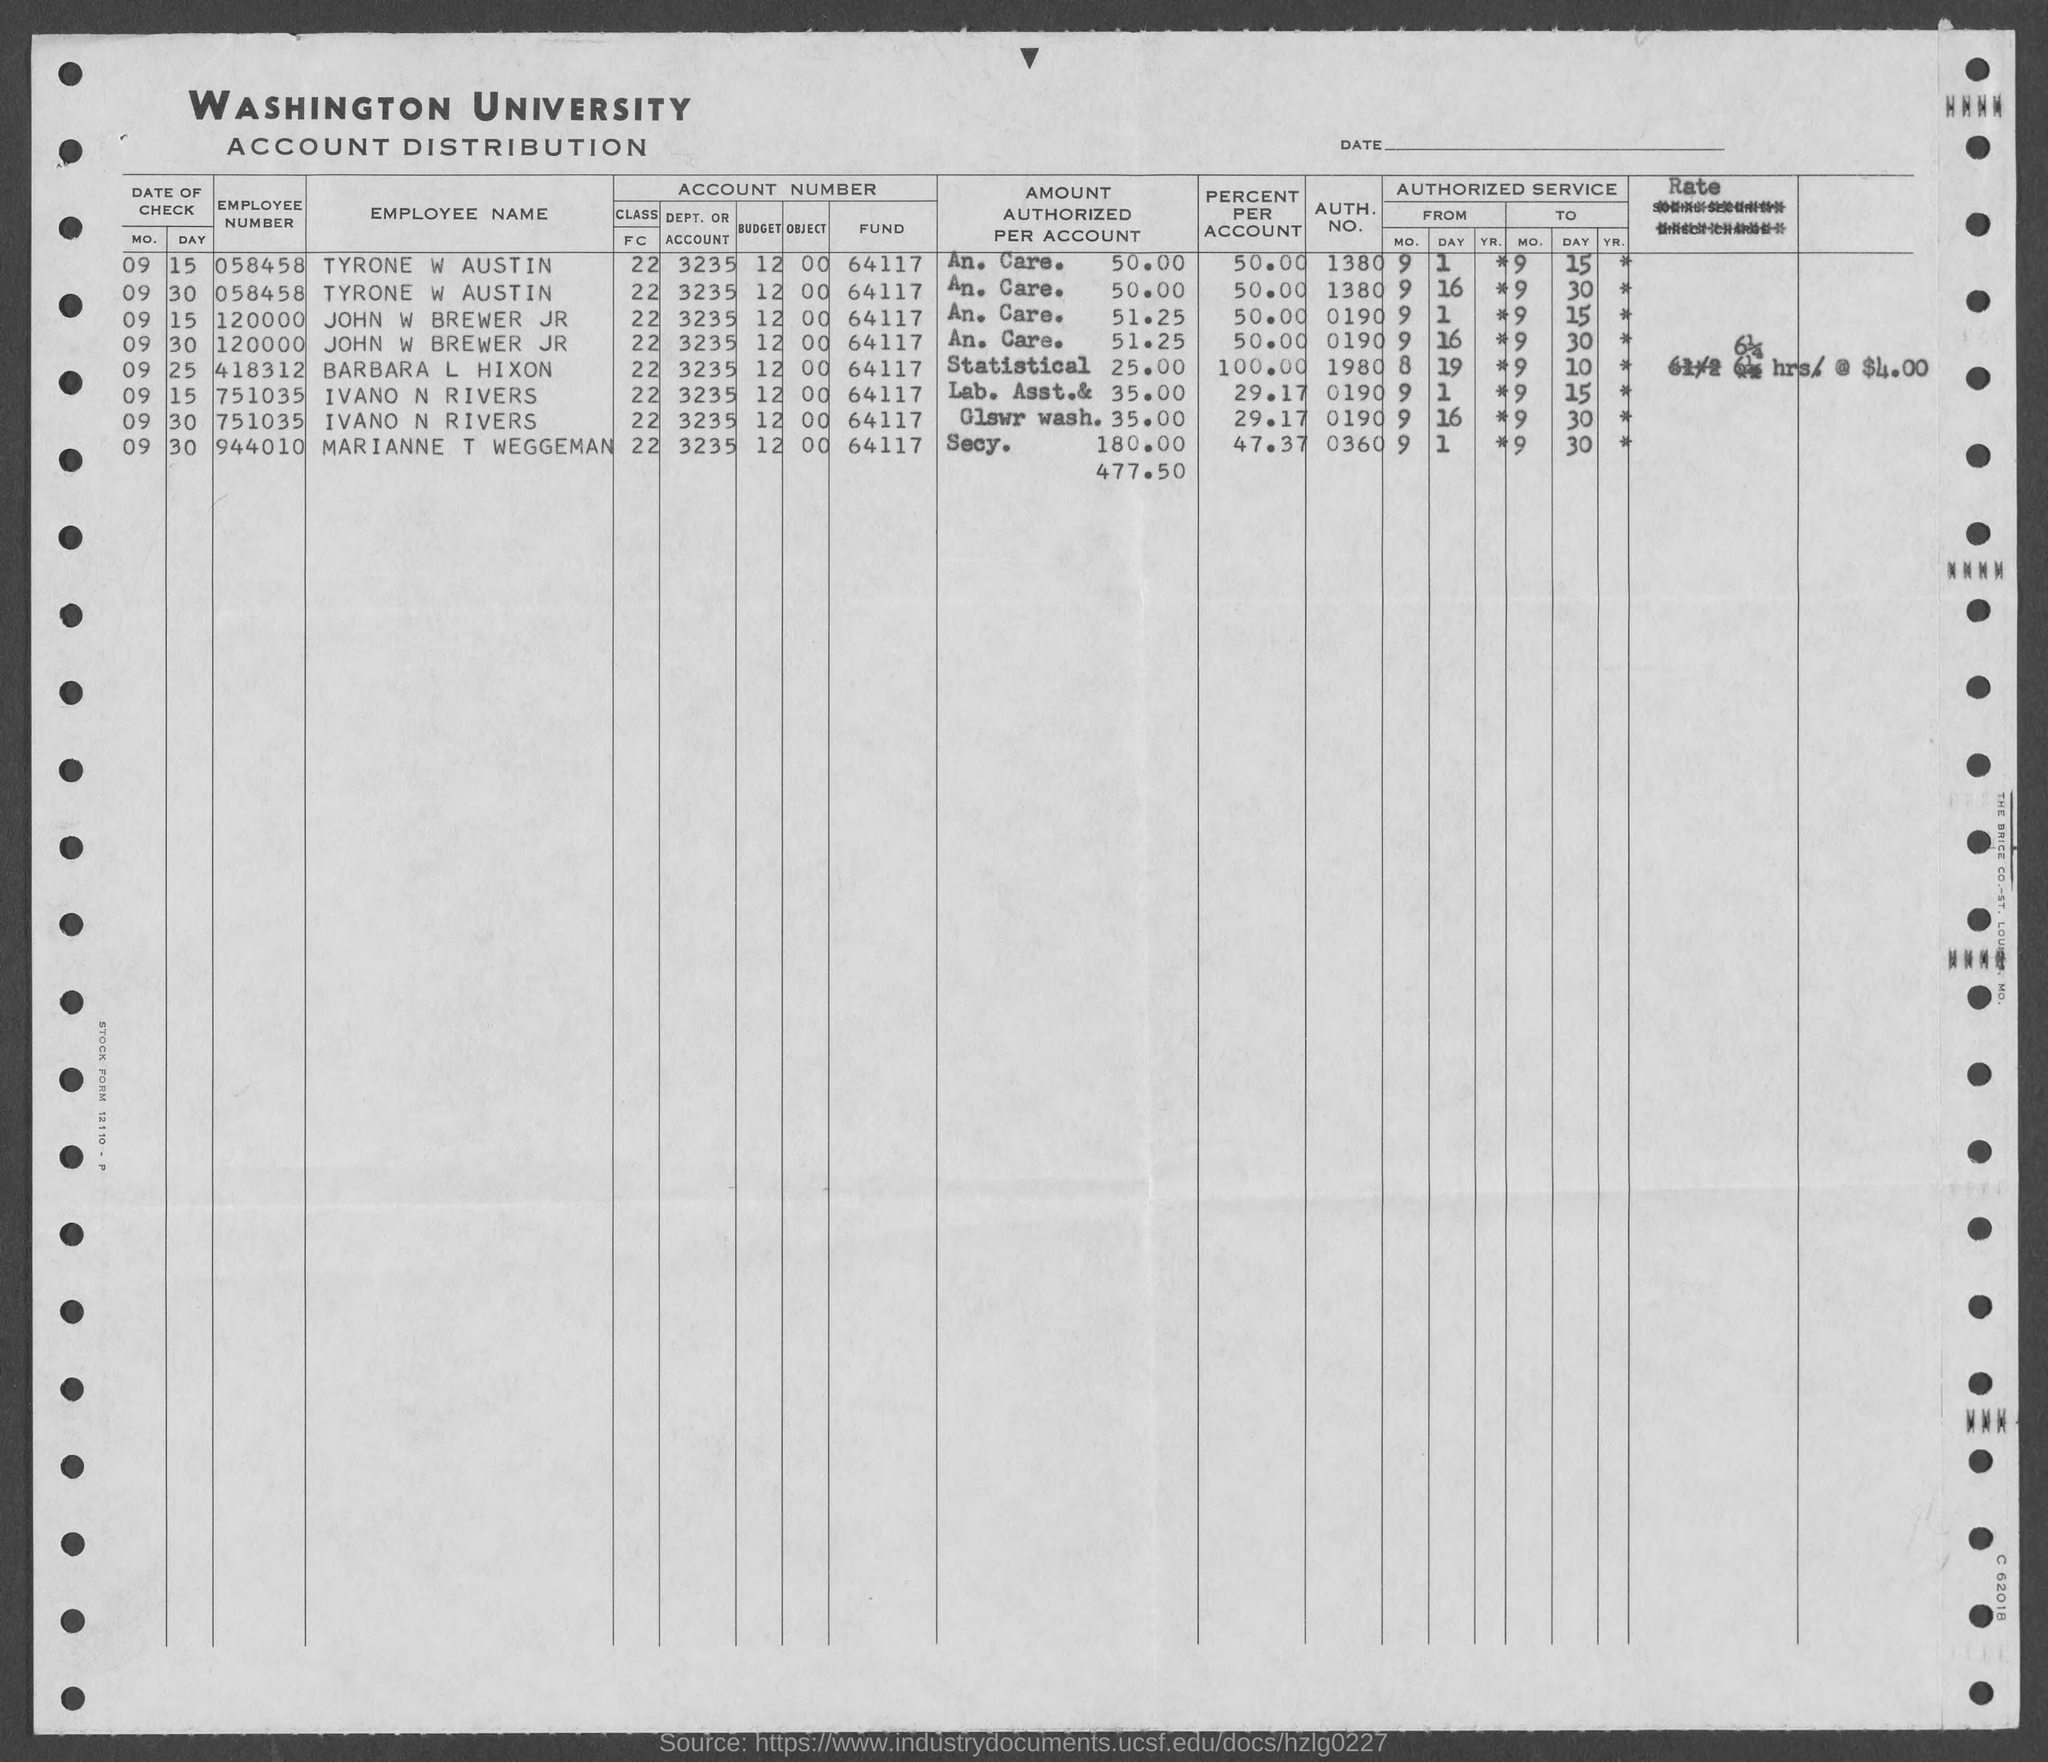What is the employee number of tyrone w austin ?
Offer a very short reply. 058458. What is the employee number of john w brewer jr ?
Give a very brief answer. 120000. What is the employee number of barbara l hixon?
Give a very brief answer. 418312. What is the employee number of ivano n rivers ?
Provide a succinct answer. 751035. What is the employee number of marianne t weggeman ?
Ensure brevity in your answer.  944010. What is the auth. no. of marianne t  weggeman?
Your response must be concise. 0360. What is the auth. no. of tyrone w austin ?
Keep it short and to the point. 1380. What is the auth. no. of  john w brewer jr?
Your answer should be compact. 0190. What is the auth. no. of barbara l hixon ?
Your answer should be very brief. 1980. What is the auth. no. of ivano n. rivers?
Offer a very short reply. 0190. 